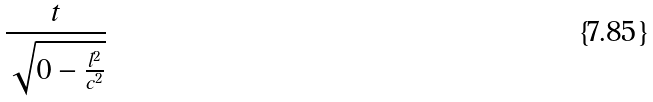<formula> <loc_0><loc_0><loc_500><loc_500>\frac { t } { \sqrt { 0 - \frac { l ^ { 2 } } { c ^ { 2 } } } }</formula> 